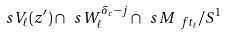Convert formula to latex. <formula><loc_0><loc_0><loc_500><loc_500>\ s V _ { \ell } ( z ^ { \prime } ) \cap \ s W _ { \ell } ^ { \delta _ { c } - j } \cap \ s M _ { \ f t _ { \ell } } / S ^ { 1 }</formula> 